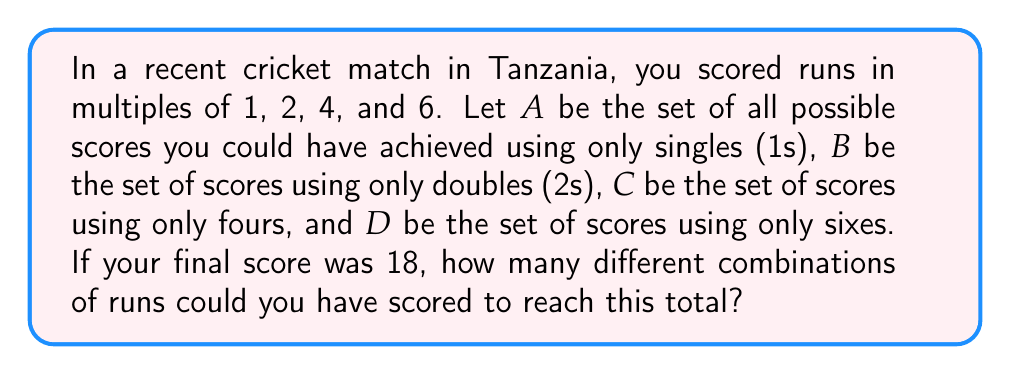Could you help me with this problem? Let's approach this step-by-step using set theory:

1) First, let's define our sets:
   A = {1, 2, 3, ..., 18}
   B = {2, 4, 6, ..., 18}
   C = {4, 8, 12, 16}
   D = {6, 12, 18}

2) We need to find all the possible combinations that sum to 18. Let's use variables:
   Let a = number of singles
   Let b = number of doubles
   Let c = number of fours
   Let d = number of sixes

3) We can express this as an equation:
   $a + 2b + 4c + 6d = 18$

4) Now, we need to find all non-negative integer solutions to this equation.

5) Let's list all possible combinations:
   - 18 singles: (18, 0, 0, 0)
   - 16 singles + 1 double: (16, 1, 0, 0)
   - 14 singles + 2 doubles: (14, 2, 0, 0)
   - 12 singles + 3 doubles: (12, 3, 0, 0)
   - 10 singles + 4 doubles: (10, 4, 0, 0)
   - 8 singles + 5 doubles: (8, 5, 0, 0)
   - 6 singles + 6 doubles: (6, 6, 0, 0)
   - 4 singles + 7 doubles: (4, 7, 0, 0)
   - 2 singles + 8 doubles: (2, 8, 0, 0)
   - 9 doubles: (0, 9, 0, 0)
   - 14 singles + 1 four: (14, 0, 1, 0)
   - 12 singles + 1 double + 1 four: (12, 1, 1, 0)
   - 10 singles + 2 doubles + 1 four: (10, 2, 1, 0)
   - 8 singles + 3 doubles + 1 four: (8, 3, 1, 0)
   - 6 singles + 4 doubles + 1 four: (6, 4, 1, 0)
   - 4 singles + 5 doubles + 1 four: (4, 5, 1, 0)
   - 2 singles + 6 doubles + 1 four: (2, 6, 1, 0)
   - 7 doubles + 1 four: (0, 7, 1, 0)
   - 10 singles + 2 fours: (10, 0, 2, 0)
   - 8 singles + 1 double + 2 fours: (8, 1, 2, 0)
   - 6 singles + 2 doubles + 2 fours: (6, 2, 2, 0)
   - 4 singles + 3 doubles + 2 fours: (4, 3, 2, 0)
   - 2 singles + 4 doubles + 2 fours: (2, 4, 2, 0)
   - 5 doubles + 2 fours: (0, 5, 2, 0)
   - 6 singles + 3 fours: (6, 0, 3, 0)
   - 4 singles + 1 double + 3 fours: (4, 1, 3, 0)
   - 2 singles + 2 doubles + 3 fours: (2, 2, 3, 0)
   - 3 doubles + 3 fours: (0, 3, 3, 0)
   - 2 singles + 4 fours: (2, 0, 4, 0)
   - 1 double + 4 fours: (0, 1, 4, 0)
   - 12 singles + 1 six: (12, 0, 0, 1)
   - 10 singles + 1 double + 1 six: (10, 1, 0, 1)
   - 8 singles + 2 doubles + 1 six: (8, 2, 0, 1)
   - 6 singles + 3 doubles + 1 six: (6, 3, 0, 1)
   - 4 singles + 4 doubles + 1 six: (4, 4, 0, 1)
   - 2 singles + 5 doubles + 1 six: (2, 5, 0, 1)
   - 6 doubles + 1 six: (0, 6, 0, 1)
   - 8 singles + 1 four + 1 six: (8, 0, 1, 1)
   - 6 singles + 1 double + 1 four + 1 six: (6, 1, 1, 1)
   - 4 singles + 2 doubles + 1 four + 1 six: (4, 2, 1, 1)
   - 2 singles + 3 doubles + 1 four + 1 six: (2, 3, 1, 1)
   - 4 doubles + 1 four + 1 six: (0, 4, 1, 1)
   - 4 singles + 2 fours + 1 six: (4, 0, 2, 1)
   - 2 singles + 1 double + 2 fours + 1 six: (2, 1, 2, 1)
   - 2 doubles + 2 fours + 1 six: (0, 2, 2, 1)
   - 3 fours + 1 six: (0, 0, 3, 1)
   - 6 singles + 2 sixes: (6, 0, 0, 2)
   - 4 singles + 1 double + 2 sixes: (4, 1, 0, 2)
   - 2 singles + 2 doubles + 2 sixes: (2, 2, 0, 2)
   - 3 doubles + 2 sixes: (0, 3, 0, 2)
   - 2 singles + 1 four + 2 sixes: (2, 0, 1, 2)
   - 1 double + 1 four + 2 sixes: (0, 1, 1, 2)
   - 3 sixes: (0, 0, 0, 3)

6) Counting all these combinations, we get 55 different ways to score 18 runs.
Answer: 55 different combinations 